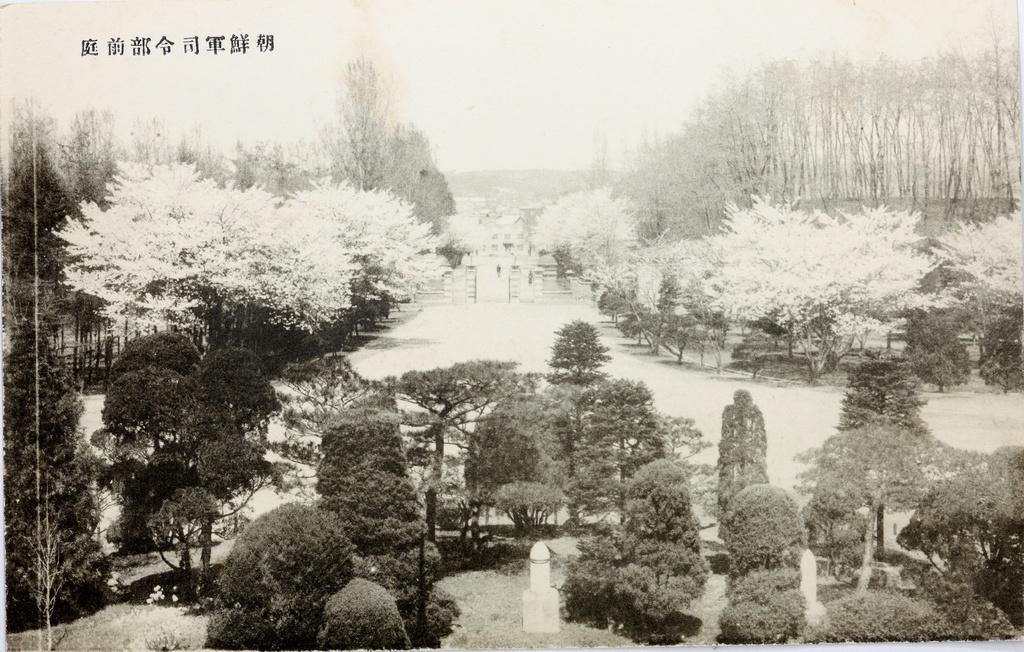What is the color scheme of the image? The image is black and white. What type of natural elements can be seen on the ground in the image? There are trees on the ground in the image. What type of man-made structures are present in the image? There are buildings in the image. What else can be seen in the image besides trees and buildings? There are objects in the image. What is visible in the background of the image? The sky is visible in the image. How does the impulse affect the chain in the image? There is no impulse or chain present in the image. 